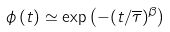<formula> <loc_0><loc_0><loc_500><loc_500>\phi \left ( t \right ) \simeq \exp \left ( - ( t / \overline { \tau } ) ^ { \beta } \right )</formula> 